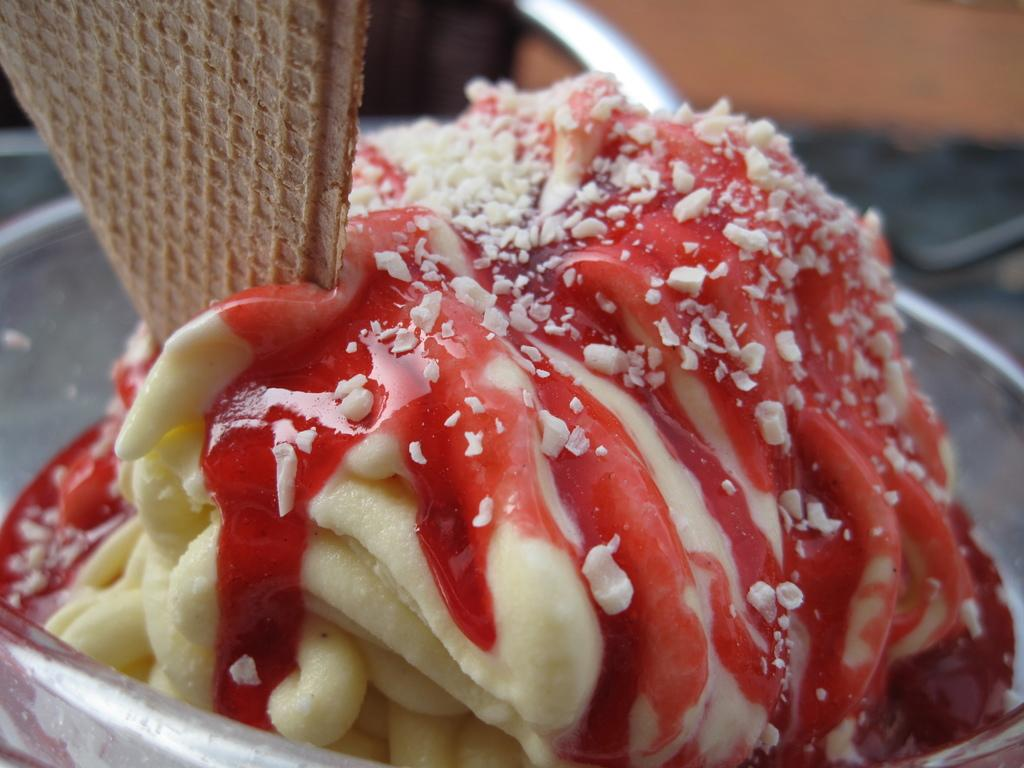What is present in the image related to food? There is food in the image. Can you describe the colors of the food in the image? The food has colors including cream, red, white, and brown. How would you describe the background of the image? The background of the image is blurred. How many legs can be seen supporting the yoke in the image? There is no yoke or legs present in the image. What type of tail is visible on the food in the image? There is no tail visible on the food in the image. 